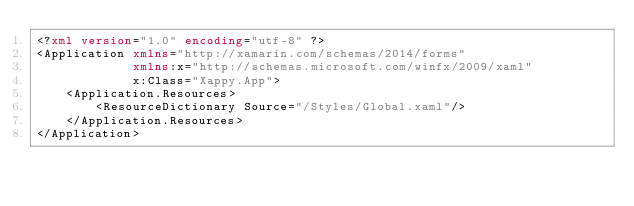<code> <loc_0><loc_0><loc_500><loc_500><_XML_><?xml version="1.0" encoding="utf-8" ?>
<Application xmlns="http://xamarin.com/schemas/2014/forms"
             xmlns:x="http://schemas.microsoft.com/winfx/2009/xaml"
             x:Class="Xappy.App">
    <Application.Resources>
        <ResourceDictionary Source="/Styles/Global.xaml"/>
    </Application.Resources>
</Application></code> 